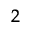Convert formula to latex. <formula><loc_0><loc_0><loc_500><loc_500>^ { 2 }</formula> 